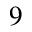Convert formula to latex. <formula><loc_0><loc_0><loc_500><loc_500>9</formula> 